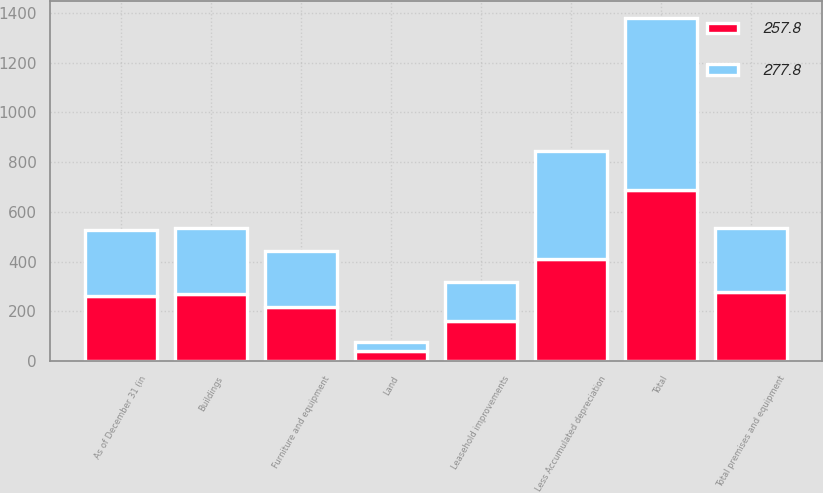Convert chart to OTSL. <chart><loc_0><loc_0><loc_500><loc_500><stacked_bar_chart><ecel><fcel>As of December 31 (in<fcel>Land<fcel>Buildings<fcel>Leasehold improvements<fcel>Furniture and equipment<fcel>Total<fcel>Less Accumulated depreciation<fcel>Total premises and equipment<nl><fcel>277.8<fcel>262.7<fcel>38.8<fcel>267.6<fcel>158.2<fcel>225.3<fcel>689.9<fcel>432.1<fcel>257.8<nl><fcel>257.8<fcel>262.7<fcel>39.5<fcel>269.2<fcel>161.6<fcel>219<fcel>689.3<fcel>411.5<fcel>277.8<nl></chart> 